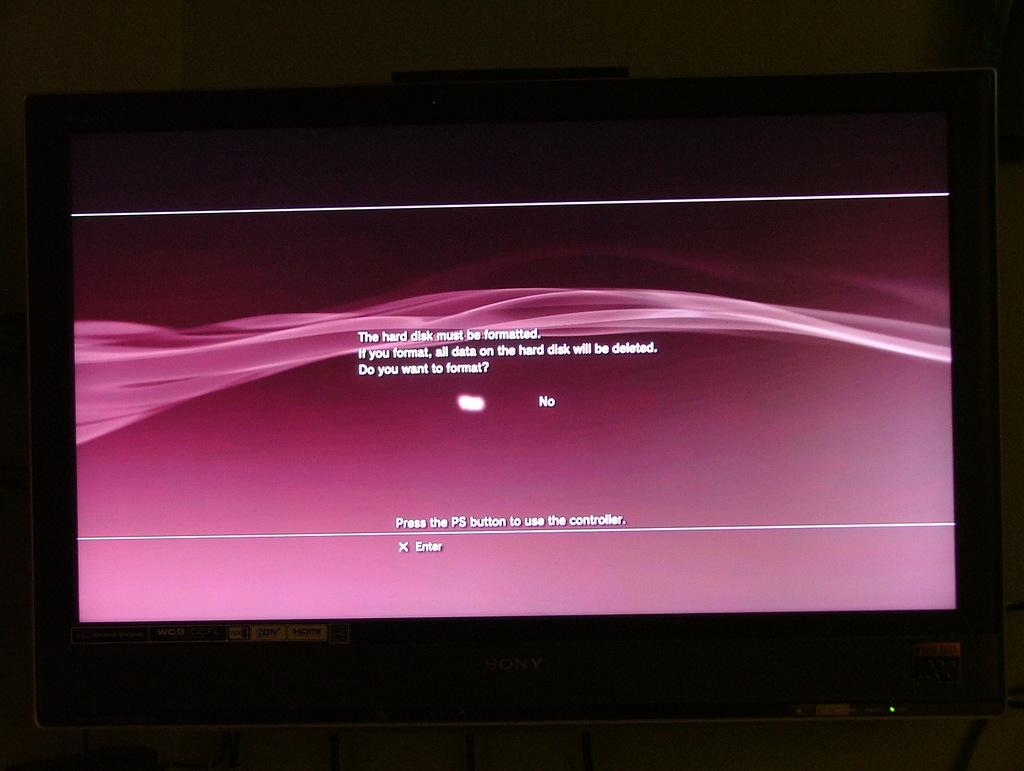<image>
Render a clear and concise summary of the photo. A computer monitor says the hard disk needs to be formatted and warns all current data will be erased if yes is chosen. 